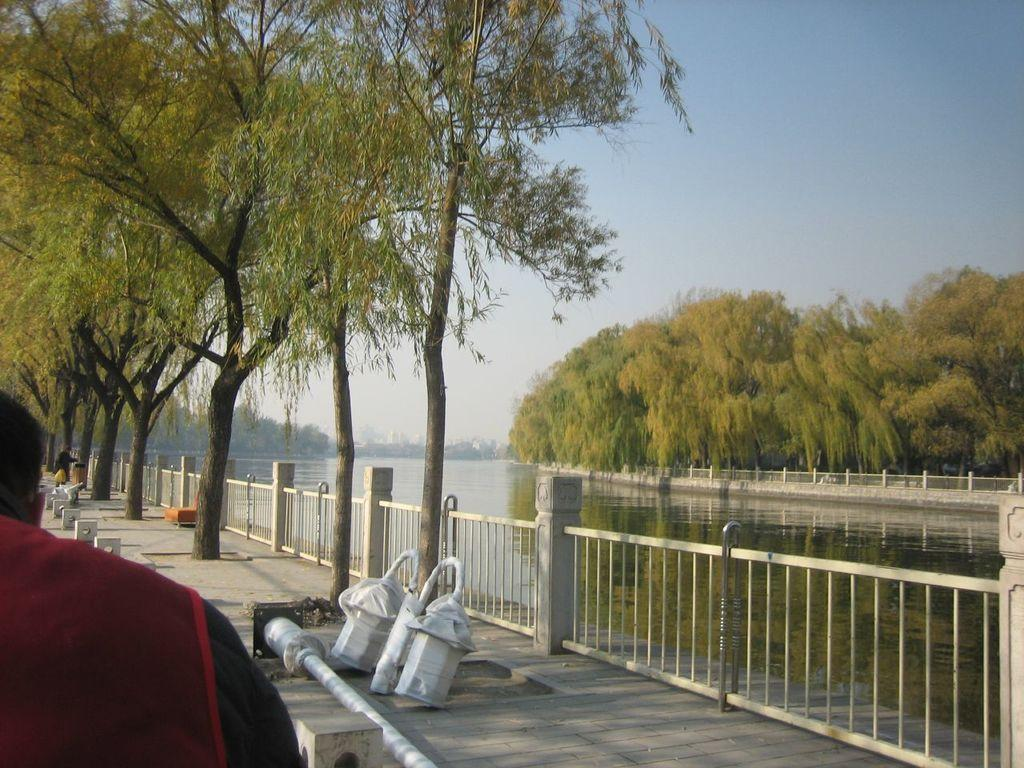What type of structure can be seen in the image? There is a fence in the image. What natural element is visible in the image? There is water visible in the image. What type of vegetation is present in the image? There are trees in the image. How many people are in the image? There are two persons in the image. What can be seen in the background of the image? The sky is visible in the background of the image. What type of crate is being used to prevent the slope from collapsing in the image? There is no crate or slope present in the image; it features a fence, water, trees, and two persons. What is the aftermath of the incident involving the persons in the image? There is no incident or aftermath depicted in the image; it shows a fence, water, trees, and two persons. 